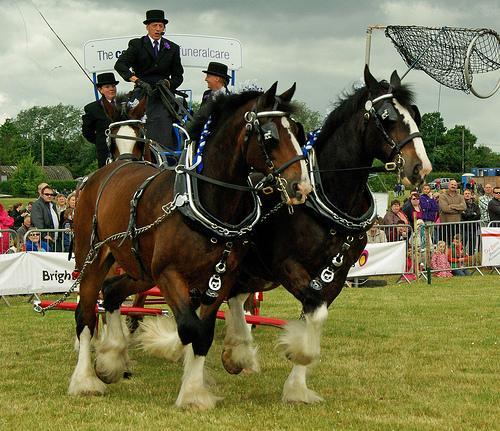Highlight something unique in the foreground or middle ground of the photo. A cone-shaped net, a green SUV in the background, and banners on a temporary metal gate add interesting details to the scene. Summarize the scenery and the people in the background of the photo. In the background, spectators observe the horse show, green trees line the horizon, and a temporary metal gate with banners can be seen. Mention a detail about the bridle and hooves of the horses. The horses have black bridles on their mouths and one of them displays white hooves. Describe the focus of the audience in the picture. Spectators, including children, are watching two clydesdale horses perform and pull a carriage with three elegantly dressed men. Explain the role of the fence and net seen in the image. A silver metal gate and a net on a pole is used to secure the area and separate the horse show from the spectators. Write a short sentence describing the animals in the image. The image features two large clydesdale horses, one brown and one black with white hooves, participating in a horse show. Discuss the attire and appearance of the people in the image. Three men in suits, including one wearing a top hat and sunglasses, accompany and ride on the carriage led by the clydesdale horses. Mention the main event happening in the picture. Two horses are performing in a show, pulling a carriage with three men in suits, in front of an audience. Narrate a brief overview of the key elements in the image. Clydesdale horses with white hooves and bridles perform in a show, pulling three men on a carriage, while spectators, including children, watch through fences. Talk about the setting and environment of the image. The picture is set in a big green lawn with trees on the horizon, grey cloudy sky above, and the green SUV in the background. 